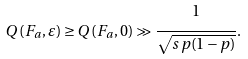<formula> <loc_0><loc_0><loc_500><loc_500>Q \left ( F _ { a } , \varepsilon \right ) \geq Q \left ( F _ { a } , 0 \right ) \gg \cfrac { 1 } { \sqrt { s \, p ( 1 - p ) } } \, .</formula> 